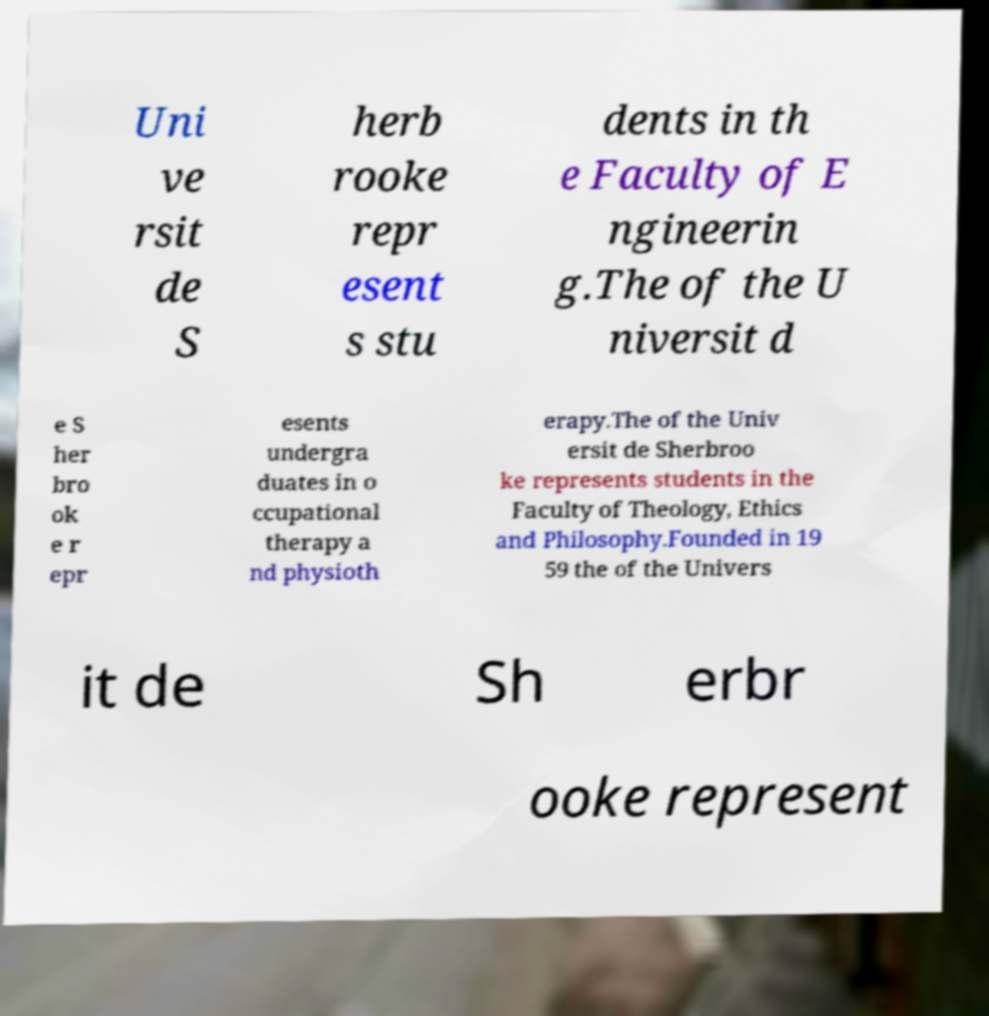There's text embedded in this image that I need extracted. Can you transcribe it verbatim? Uni ve rsit de S herb rooke repr esent s stu dents in th e Faculty of E ngineerin g.The of the U niversit d e S her bro ok e r epr esents undergra duates in o ccupational therapy a nd physioth erapy.The of the Univ ersit de Sherbroo ke represents students in the Faculty of Theology, Ethics and Philosophy.Founded in 19 59 the of the Univers it de Sh erbr ooke represent 